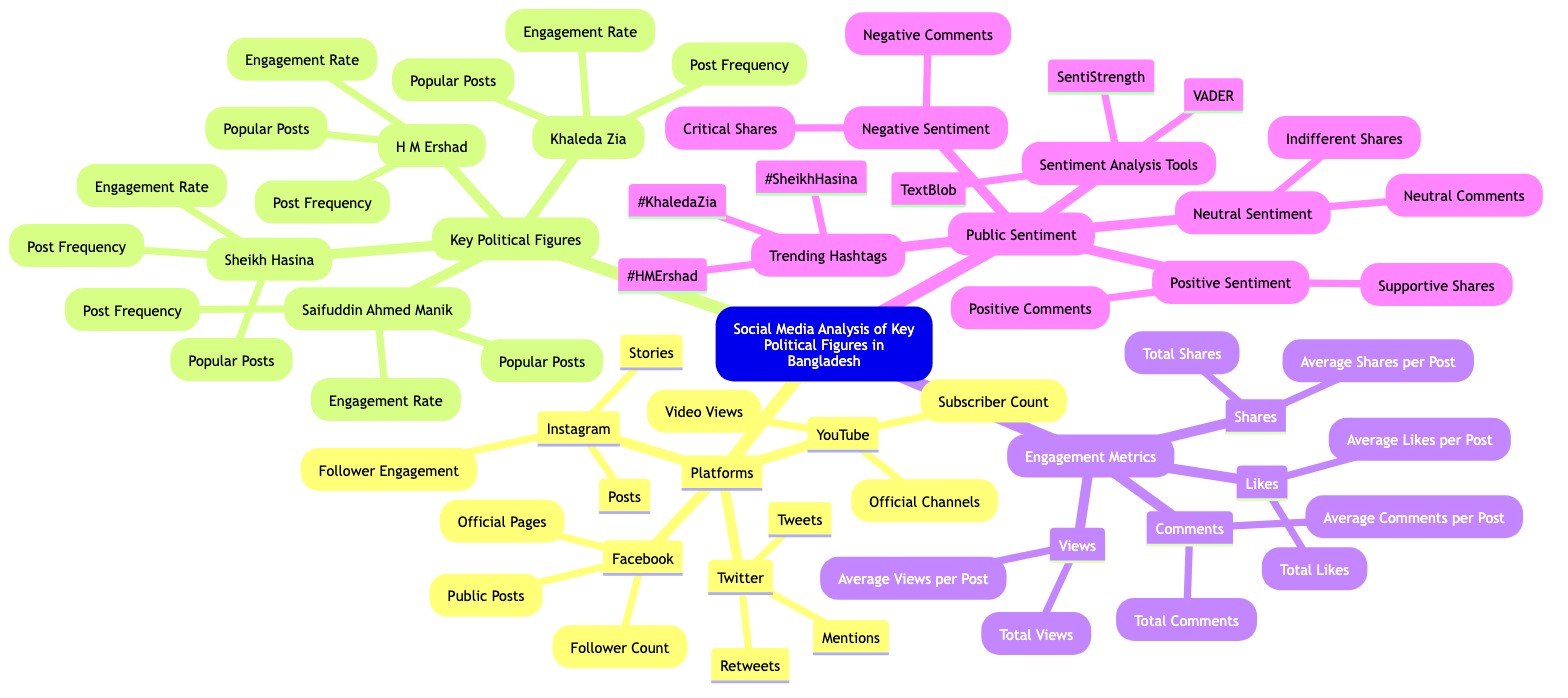What platforms are included in the analysis? The diagram lists four platforms under "Platforms," which are Facebook, Twitter, YouTube, and Instagram.
Answer: Facebook, Twitter, YouTube, Instagram Who are the key political figures analyzed? The diagram identifies four key political figures: Sheikh Hasina, Khaleda Zia, H M Ershad, and Saifuddin Ahmed Manik.
Answer: Sheikh Hasina, Khaleda Zia, H M Ershad, Saifuddin Ahmed Manik What metric is included under Engagement Metrics for comments? Within the "Engagement Metrics" section, "Total Comments" is listed as one of the metrics.
Answer: Total Comments Which sentiment analysis tools are mentioned? The diagram provides three tools under "Sentiment Analysis Tools": TextBlob, VADER, and SentiStrength.
Answer: TextBlob, VADER, SentiStrength What common aspect is measured for all key political figures? The common aspect for all key political figures analyzed is "Engagement Rate," which is present for each political figure.
Answer: Engagement Rate How many types of sentiment are analyzed in the Public Sentiment section? The diagram lists three types of sentiment under "Public Sentiment": Positive Sentiment, Negative Sentiment, and Neutral Sentiment.
Answer: Three Which social media platform includes "Subscriber Count"? "Subscriber Count" is specifically mentioned under the YouTube section of the diagram, indicating its relevance to that platform.
Answer: YouTube What do the engagement metrics collect data about likes? Under "Likes," the engagement metrics include "Total Likes" and "Average Likes per Post."
Answer: Total Likes, Average Likes per Post How many engagement metrics are identified in total? The diagram features four categories for engagement metrics: Likes, Comments, Shares, and Views. Therefore, there are four engagement metrics identified.
Answer: Four 